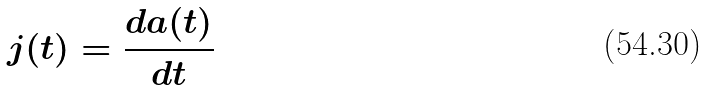<formula> <loc_0><loc_0><loc_500><loc_500>j ( t ) = \frac { d a ( t ) } { d t }</formula> 